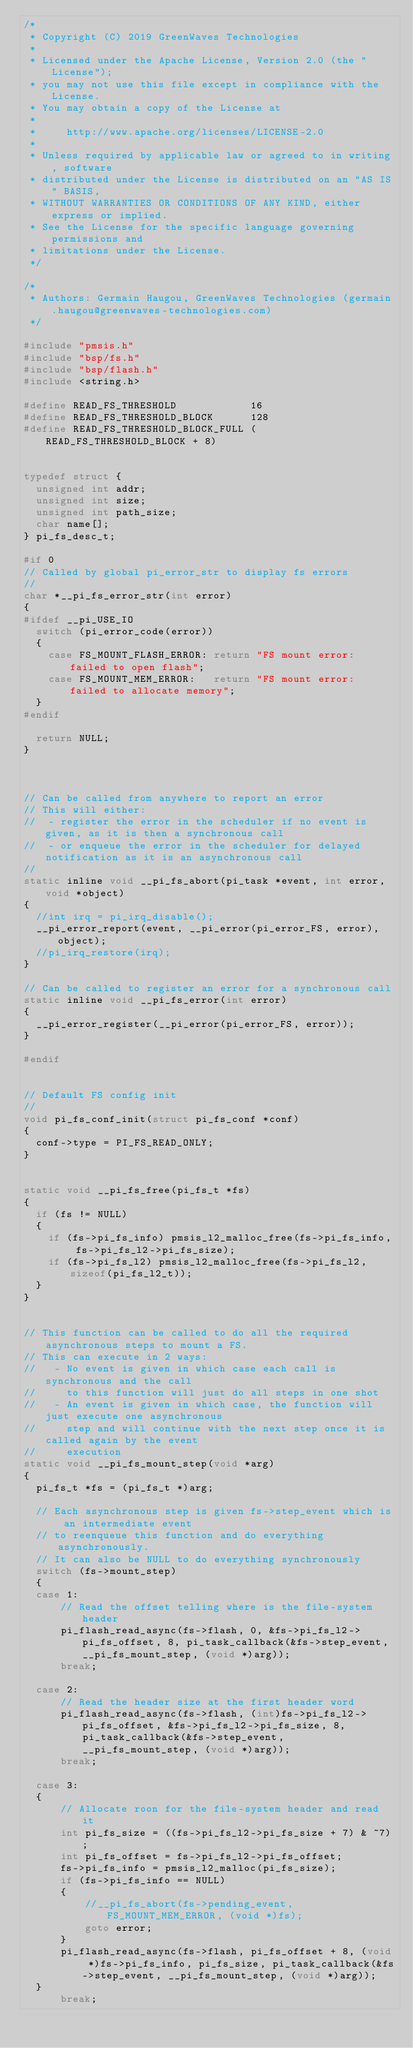<code> <loc_0><loc_0><loc_500><loc_500><_C_>/*
 * Copyright (C) 2019 GreenWaves Technologies
 *
 * Licensed under the Apache License, Version 2.0 (the "License");
 * you may not use this file except in compliance with the License.
 * You may obtain a copy of the License at
 *
 *     http://www.apache.org/licenses/LICENSE-2.0
 *
 * Unless required by applicable law or agreed to in writing, software
 * distributed under the License is distributed on an "AS IS" BASIS,
 * WITHOUT WARRANTIES OR CONDITIONS OF ANY KIND, either express or implied.
 * See the License for the specific language governing permissions and
 * limitations under the License.
 */

/*
 * Authors: Germain Haugou, GreenWaves Technologies (germain.haugou@greenwaves-technologies.com)
 */

#include "pmsis.h"
#include "bsp/fs.h"
#include "bsp/flash.h"
#include <string.h>

#define READ_FS_THRESHOLD            16
#define READ_FS_THRESHOLD_BLOCK      128
#define READ_FS_THRESHOLD_BLOCK_FULL (READ_FS_THRESHOLD_BLOCK + 8)


typedef struct {
  unsigned int addr;
  unsigned int size;
  unsigned int path_size;
  char name[];
} pi_fs_desc_t;

#if 0
// Called by global pi_error_str to display fs errors
//
char *__pi_fs_error_str(int error)
{
#ifdef __pi_USE_IO
  switch (pi_error_code(error))
  {
    case FS_MOUNT_FLASH_ERROR: return "FS mount error: failed to open flash";
    case FS_MOUNT_MEM_ERROR:   return "FS mount error: failed to allocate memory";
  }
#endif

  return NULL;
}



// Can be called from anywhere to report an error
// This will either:
//  - register the error in the scheduler if no event is given, as it is then a synchronous call
//  - or enqueue the error in the scheduler for delayed notification as it is an asynchronous call
//
static inline void __pi_fs_abort(pi_task *event, int error, void *object)
{
  //int irq = pi_irq_disable();
  __pi_error_report(event, __pi_error(pi_error_FS, error), object);
  //pi_irq_restore(irq);
}

// Can be called to register an error for a synchronous call
static inline void __pi_fs_error(int error)
{
  __pi_error_register(__pi_error(pi_error_FS, error));
}

#endif


// Default FS config init
//
void pi_fs_conf_init(struct pi_fs_conf *conf)
{
  conf->type = PI_FS_READ_ONLY;
}


static void __pi_fs_free(pi_fs_t *fs)
{
  if (fs != NULL)
  {
    if (fs->pi_fs_info) pmsis_l2_malloc_free(fs->pi_fs_info, fs->pi_fs_l2->pi_fs_size);
    if (fs->pi_fs_l2) pmsis_l2_malloc_free(fs->pi_fs_l2, sizeof(pi_fs_l2_t));
  }
}


// This function can be called to do all the required asynchronous steps to mount a FS.
// This can execute in 2 ways:
//   - No event is given in which case each call is synchronous and the call
//     to this function will just do all steps in one shot
//   - An event is given in which case, the function will just execute one asynchronous
//     step and will continue with the next step once it is called again by the event
//     execution
static void __pi_fs_mount_step(void *arg)
{
  pi_fs_t *fs = (pi_fs_t *)arg;

  // Each asynchronous step is given fs->step_event which is an intermediate event
  // to reenqueue this function and do everything asynchronously.
  // It can also be NULL to do everything synchronously
  switch (fs->mount_step)
  {
  case 1:
      // Read the offset telling where is the file-system header
      pi_flash_read_async(fs->flash, 0, &fs->pi_fs_l2->pi_fs_offset, 8, pi_task_callback(&fs->step_event, __pi_fs_mount_step, (void *)arg));
      break;

  case 2:
      // Read the header size at the first header word
      pi_flash_read_async(fs->flash, (int)fs->pi_fs_l2->pi_fs_offset, &fs->pi_fs_l2->pi_fs_size, 8, pi_task_callback(&fs->step_event, __pi_fs_mount_step, (void *)arg));
      break;

  case 3:
  {
      // Allocate roon for the file-system header and read it
      int pi_fs_size = ((fs->pi_fs_l2->pi_fs_size + 7) & ~7);
      int pi_fs_offset = fs->pi_fs_l2->pi_fs_offset;
      fs->pi_fs_info = pmsis_l2_malloc(pi_fs_size);
      if (fs->pi_fs_info == NULL)
      {
          //__pi_fs_abort(fs->pending_event, FS_MOUNT_MEM_ERROR, (void *)fs);
          goto error;
      }
      pi_flash_read_async(fs->flash, pi_fs_offset + 8, (void *)fs->pi_fs_info, pi_fs_size, pi_task_callback(&fs->step_event, __pi_fs_mount_step, (void *)arg));
  }
      break;
</code> 